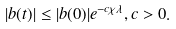<formula> <loc_0><loc_0><loc_500><loc_500>| b ( t ) | \leq | b ( 0 ) | e ^ { - c \chi \lambda } , c > 0 .</formula> 